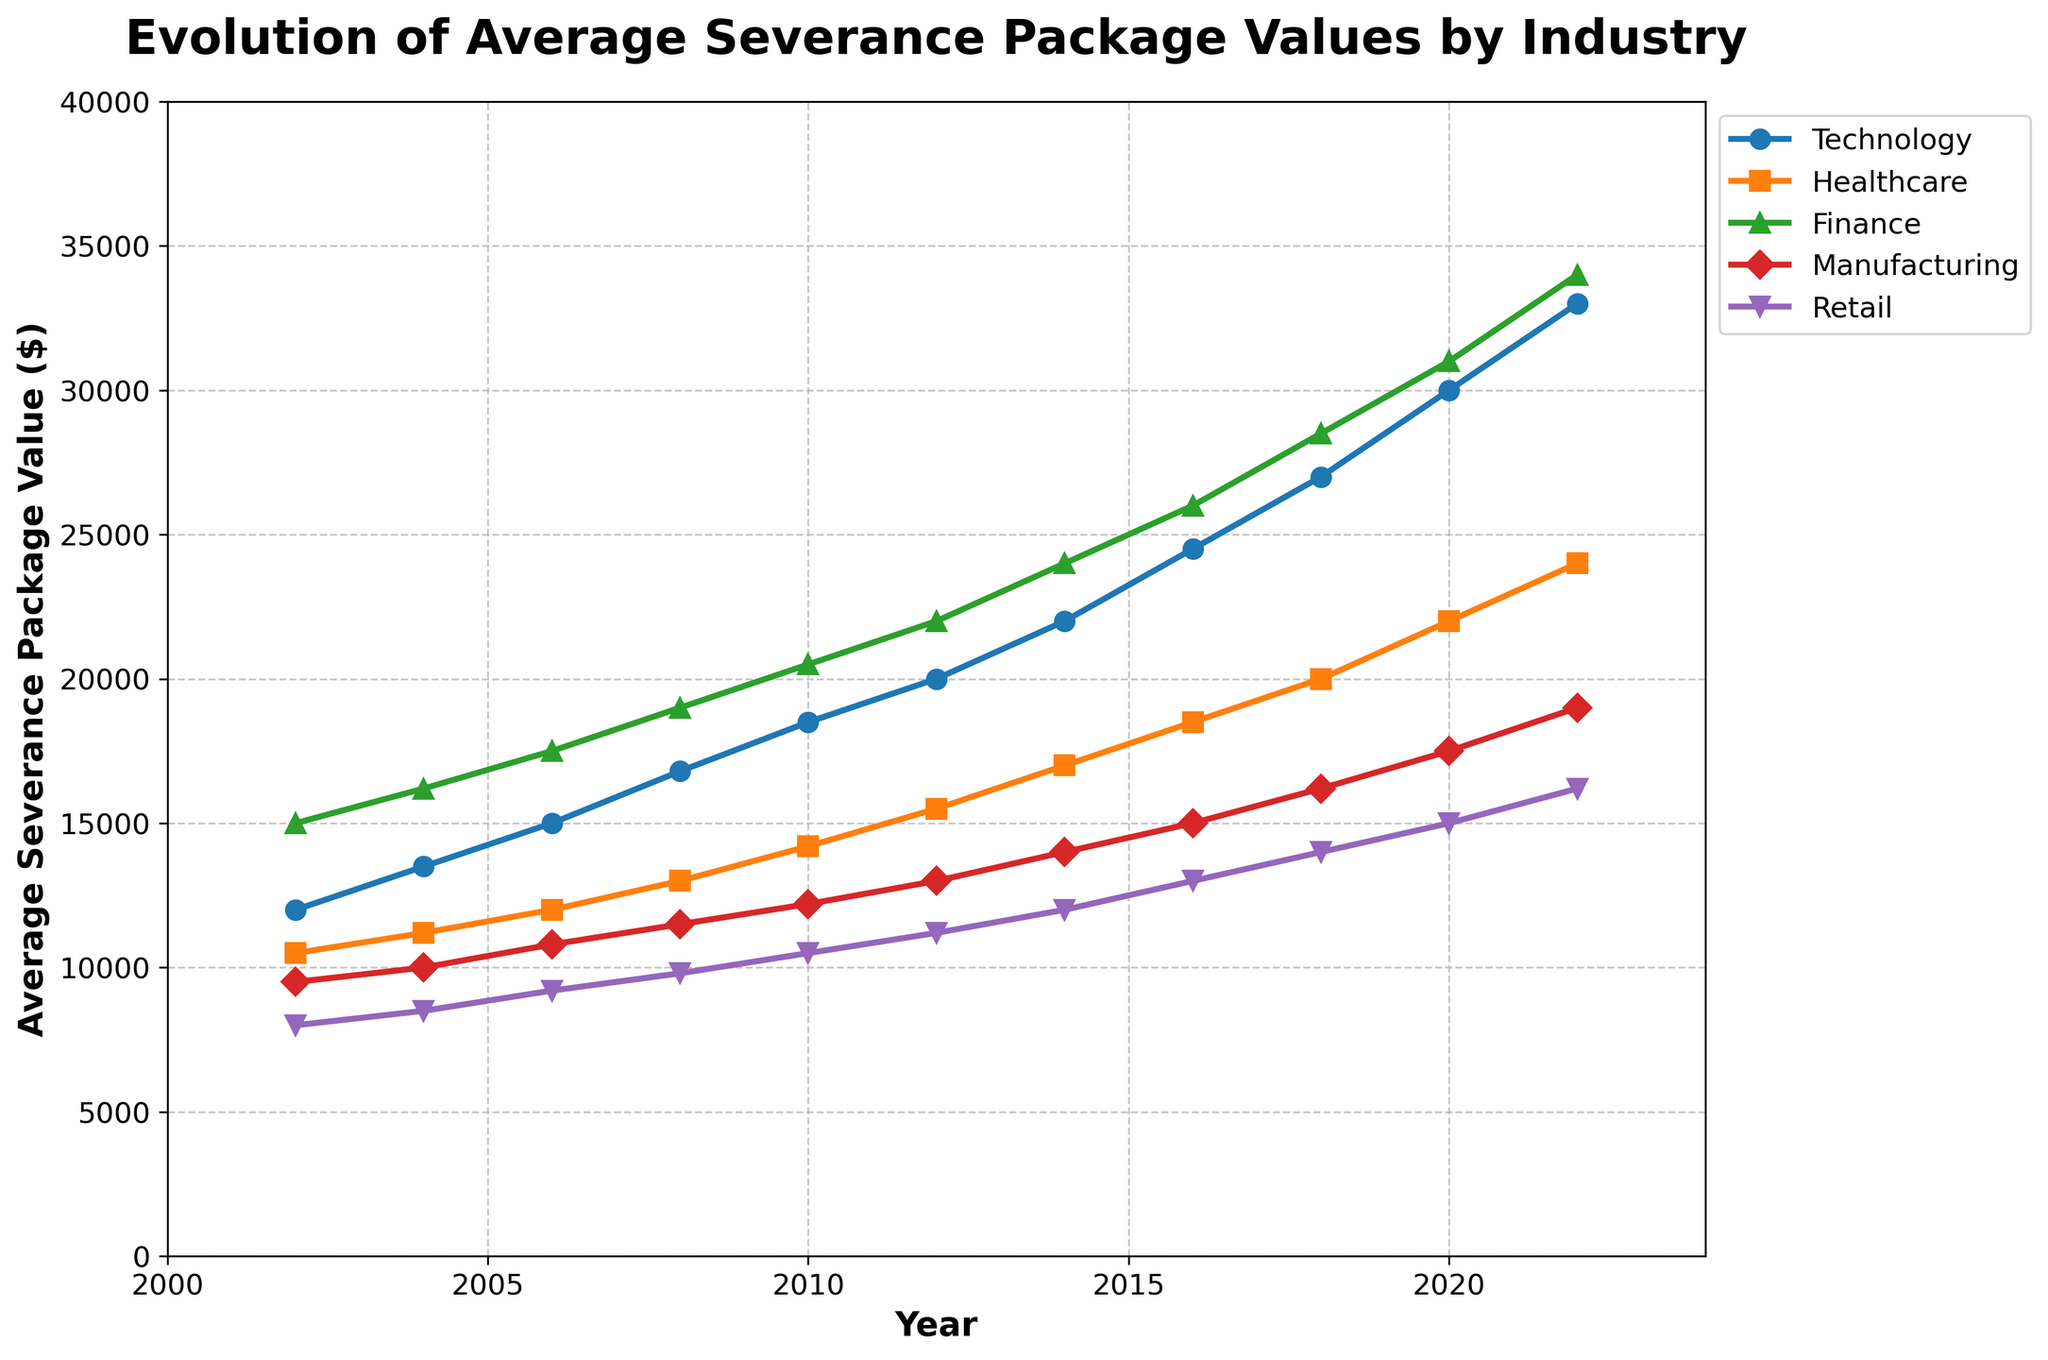What industry had the fastest growth in average severance package values from 2002 to 2022? Examine the figure and compare the slopes of the lines representing each industry from 2002 to 2022. The steepest line indicates the fastest growth.
Answer: Technology What is the difference in the average severance package value between the Technology and Healthcare industries in 2022? Look at the end points of the lines for Technology and Healthcare in 2022 and subtract the Healthcare value from the Technology value.
Answer: $9,000 Which industry had the highest average severance package value in 2010? Identify the line with the highest point at the 2010 mark on the x-axis.
Answer: Finance What trend can be observed in the Manufacturing industry’s severance package values over the two decades? Follow the Manufacturing line from 2002 to 2022, observing the consistent increase in the values.
Answer: Increasing What year did the Retail industry first reach an average severance package value of $15,000 or higher? Follow the Retail line and identify the first point where it reaches or exceeds $15,000.
Answer: 2020 Which industries saw their average severance package values more than double from 2002 to 2022? Compare the endpoints of each industry's line between 2002 and 2022, and check if the final value is more than twice the initial value.
Answer: Technology, Healthcare, Finance, Manufacturing By how much did the average severance package value in the Finance industry increase from 2006 to 2018? Identify the values for Finance in 2006 and 2018 and subtract the 2006 value from the 2018 value.
Answer: $11,000 What is the average severance package value across all industries in 2014? Identify the values for each industry in 2014, sum them up, and divide by the number of industries. (22000 + 17000 + 24000 + 14000 + 12000) / 5
Answer: $17,800 Which two industries had the closest average severance package values in 2020? Compare the values for each industry in 2020 and find the pair with the smallest difference.
Answer: Healthcare and Finance How does the growth pattern of the severance packages in the Manufacturing industry compare to that in the Technology industry from 2002 to 2022? Compare the slope and increments between the two lines representing Manufacturing and Technology over the years. Manufacturing shows a steady, moderate increase, whereas Technology shows a sharp, continuous rise.
Answer: Manufacturing has moderate growth; Technology has sharp growth 